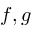<formula> <loc_0><loc_0><loc_500><loc_500>f , g</formula> 